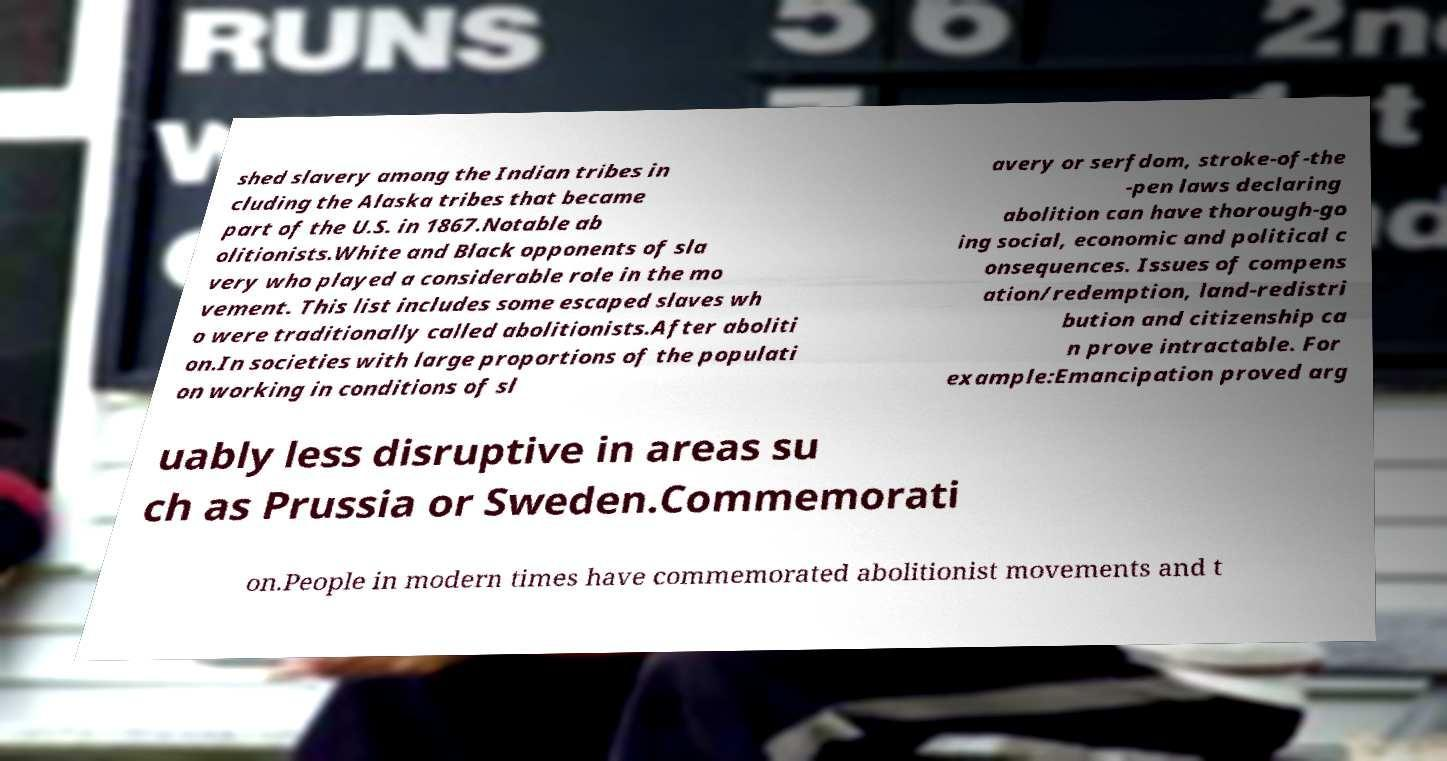Please read and relay the text visible in this image. What does it say? shed slavery among the Indian tribes in cluding the Alaska tribes that became part of the U.S. in 1867.Notable ab olitionists.White and Black opponents of sla very who played a considerable role in the mo vement. This list includes some escaped slaves wh o were traditionally called abolitionists.After aboliti on.In societies with large proportions of the populati on working in conditions of sl avery or serfdom, stroke-of-the -pen laws declaring abolition can have thorough-go ing social, economic and political c onsequences. Issues of compens ation/redemption, land-redistri bution and citizenship ca n prove intractable. For example:Emancipation proved arg uably less disruptive in areas su ch as Prussia or Sweden.Commemorati on.People in modern times have commemorated abolitionist movements and t 